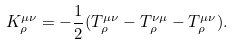<formula> <loc_0><loc_0><loc_500><loc_500>K ^ { \mu \nu } _ { \rho } = - \frac { 1 } { 2 } ( T ^ { \mu \nu } _ { \rho } - T ^ { \nu \mu } _ { \rho } - T _ { \rho } ^ { \mu \nu } ) .</formula> 